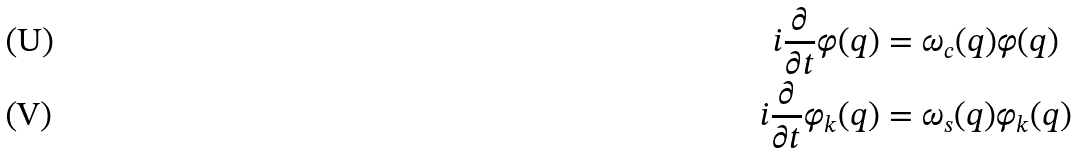Convert formula to latex. <formula><loc_0><loc_0><loc_500><loc_500>i \frac { \partial } { \partial t } \varphi ( q ) & = \omega _ { c } ( q ) \varphi ( q ) \\ i \frac { \partial } { \partial t } \varphi _ { k } ( q ) & = \omega _ { s } ( q ) \varphi _ { k } ( q )</formula> 